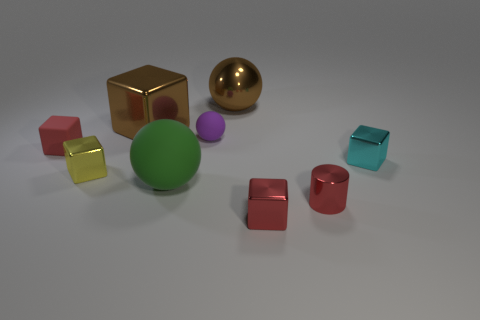Subtract all large matte balls. How many balls are left? 2 Subtract all gray cylinders. How many red cubes are left? 2 Subtract all red blocks. How many blocks are left? 3 Subtract all cubes. How many objects are left? 4 Add 2 blue rubber cylinders. How many blue rubber cylinders exist? 2 Subtract 0 purple cubes. How many objects are left? 9 Subtract all blue blocks. Subtract all yellow balls. How many blocks are left? 5 Subtract all large brown shiny cubes. Subtract all tiny red cubes. How many objects are left? 6 Add 2 red shiny cubes. How many red shiny cubes are left? 3 